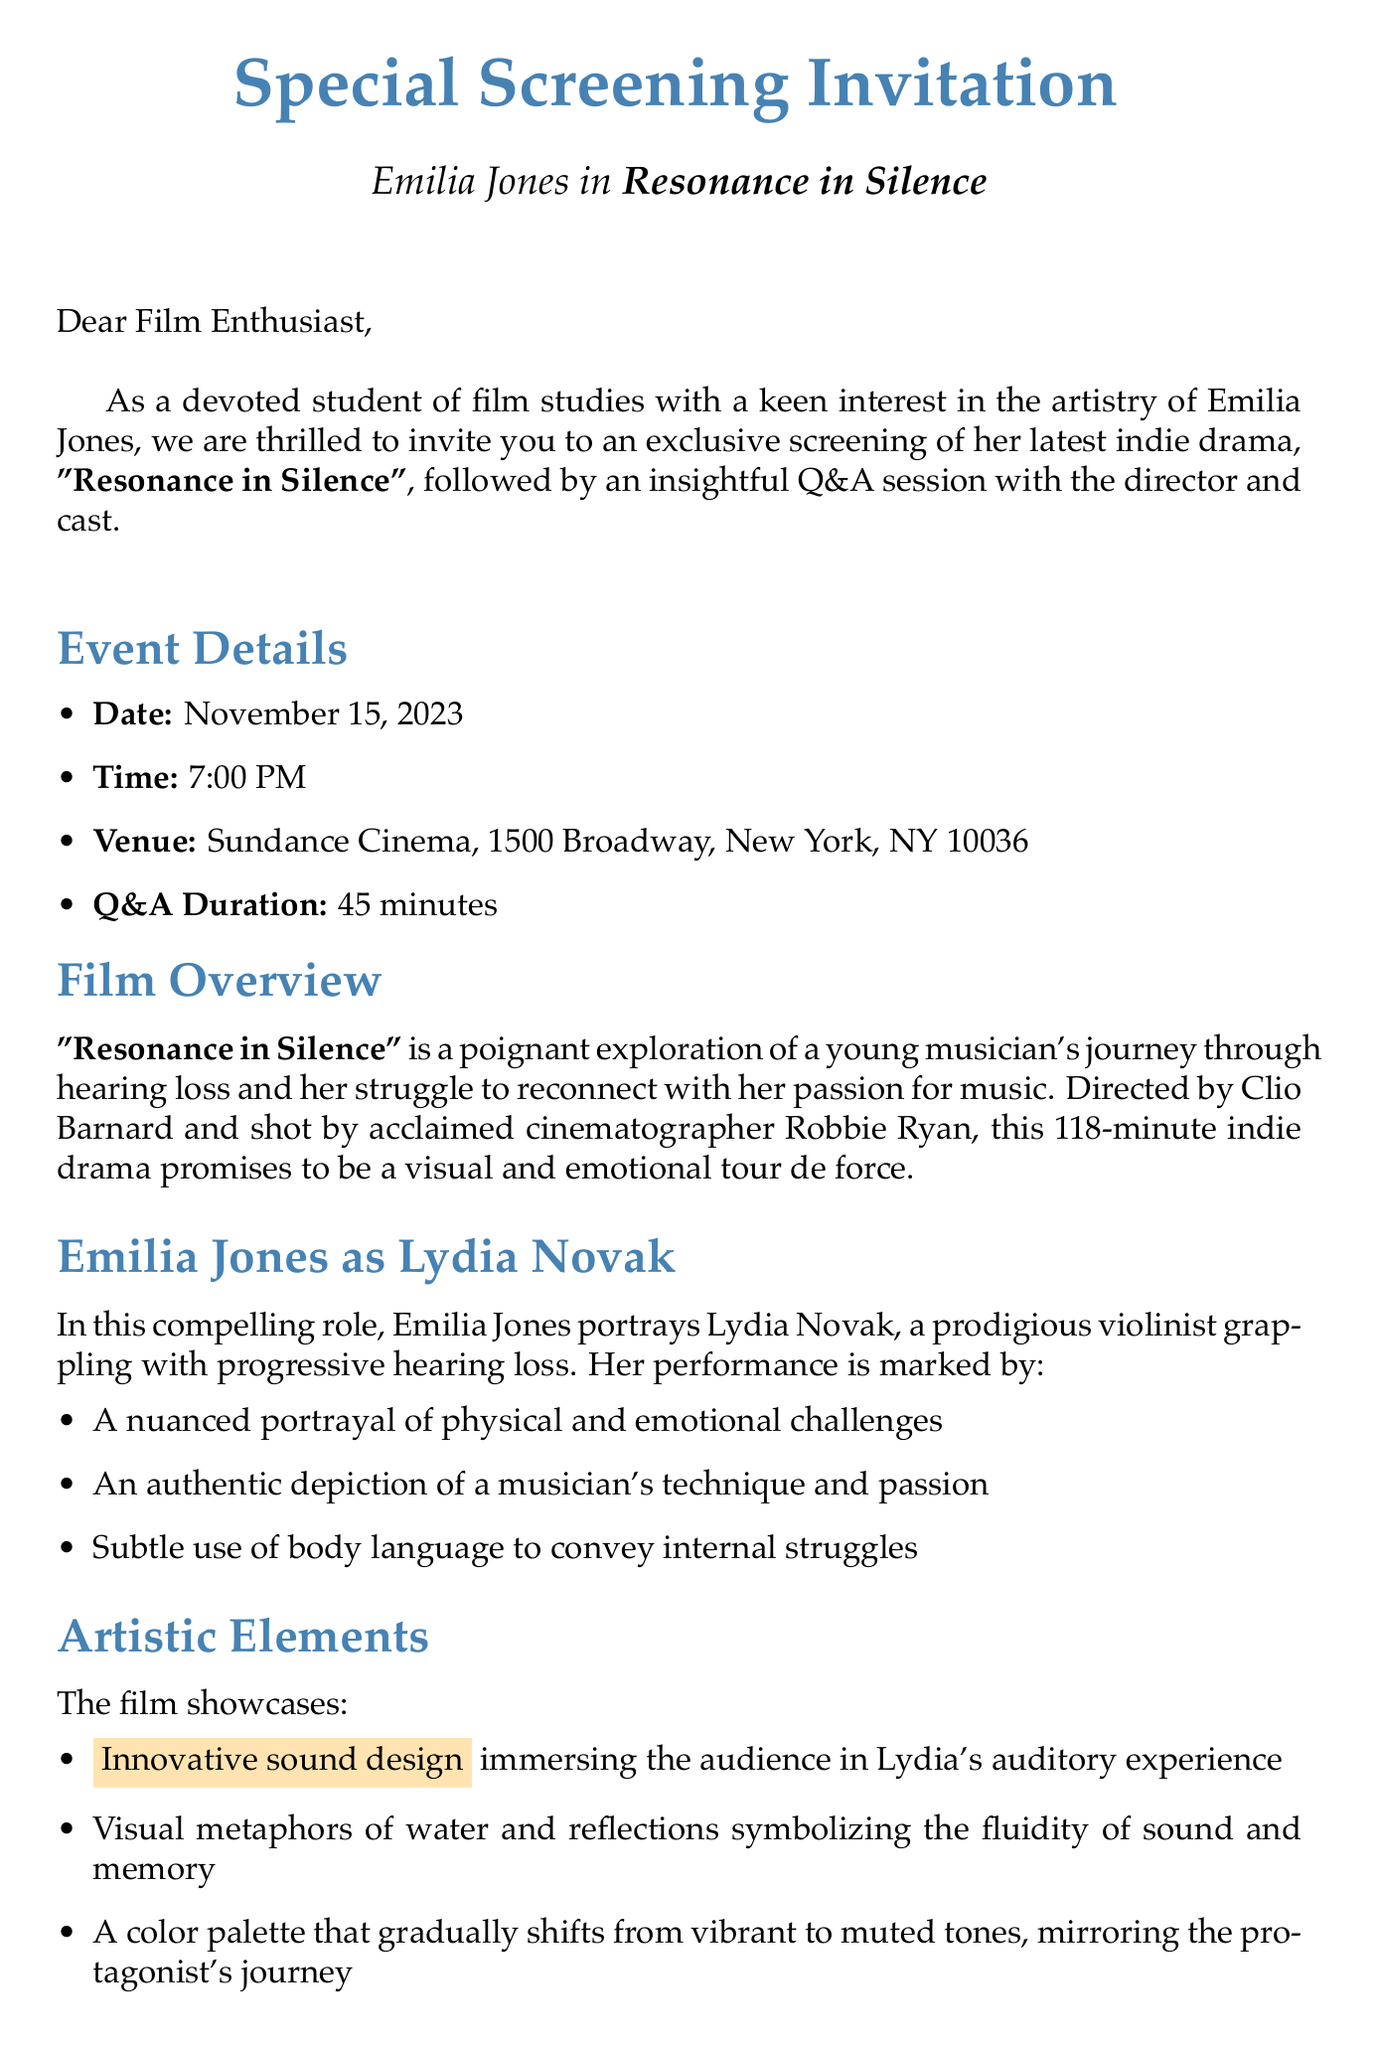What is the title of the film? The title of the film is mentioned in the event details of the document.
Answer: Resonance in Silence What is the screening date? The screening date is specified in the event details section.
Answer: November 15, 2023 Who is the director of the film? The director is indicated in the film overview section of the letter.
Answer: Clio Barnard What role does Emilia Jones play? The character played by Emilia Jones is detailed in the Emilia Jones as Lydia Novak section.
Answer: Lydia Novak What is the runtime of the film? The runtime is given in the film overview part of the document.
Answer: 118 minutes How many minutes will the Q&A session last? The duration of the Q&A session is stated in the event details.
Answer: 45 minutes What artistic element uses innovative sound design? The artistic elements section describes various techniques used in the film.
Answer: Sound design What themes are relevant to film studies based on this film? The film studies relevance section outlines specific themes for discussion.
Answer: Performance techniques How many attendees are expected for the screening? The seating capacity is provided in the RSVP details section.
Answer: Limited to 150 attendees What is the contact email for RSVP? The contact email for RSVP is listed in the RSVP details section.
Answer: screenings@sundancecinema.com 